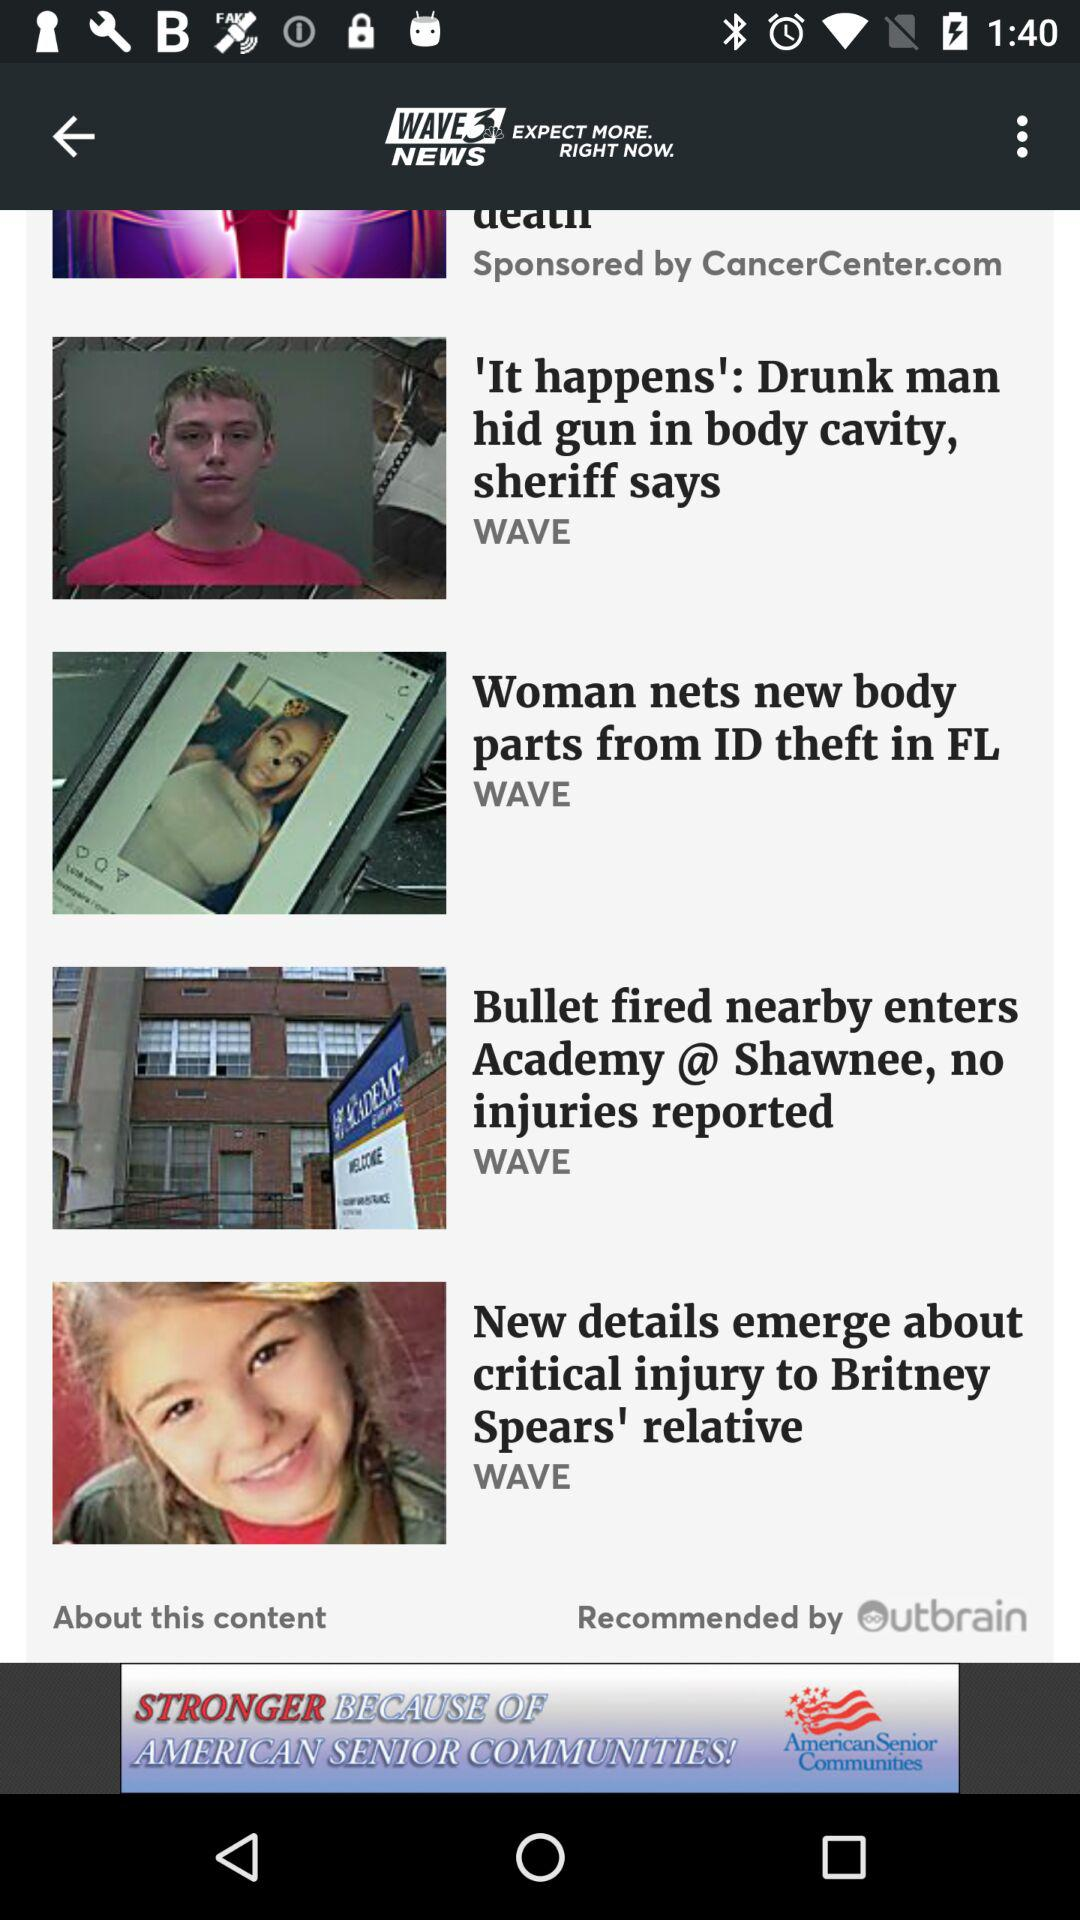What is the app name? The app name is "WAVE3 NEWS". 